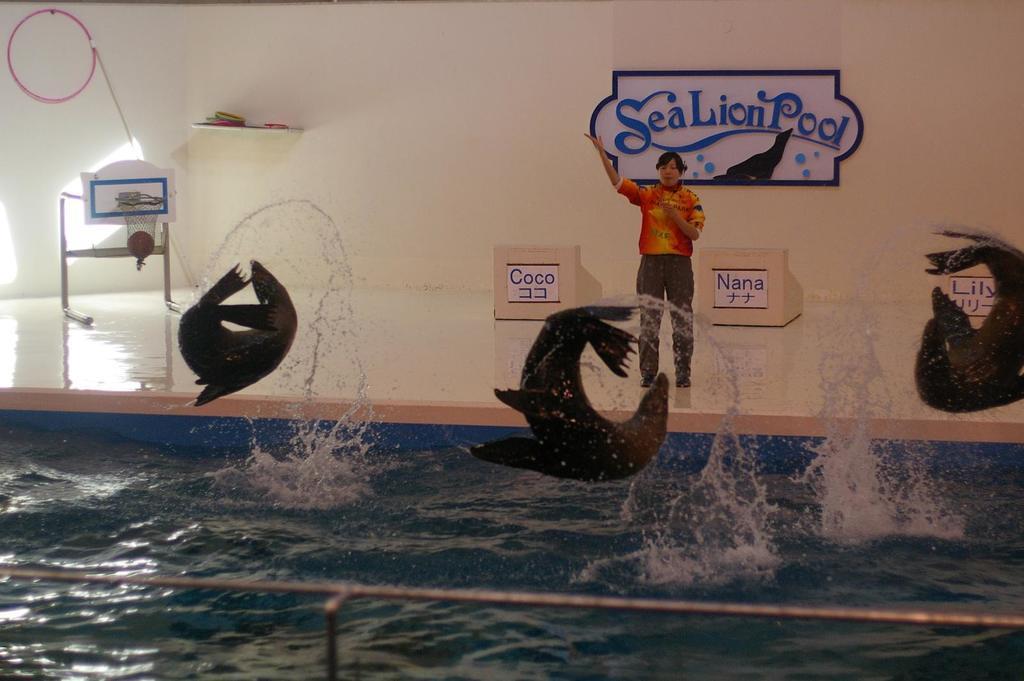Can you describe this image briefly? In this picture there are three dolphins jumping from the water. On the bottom we can see swimming pool. Here we can see a person who is wearing shirt, jeans and shoe, standing near to the desk. Here we can see board. On the left there is a stand near to the wall. 